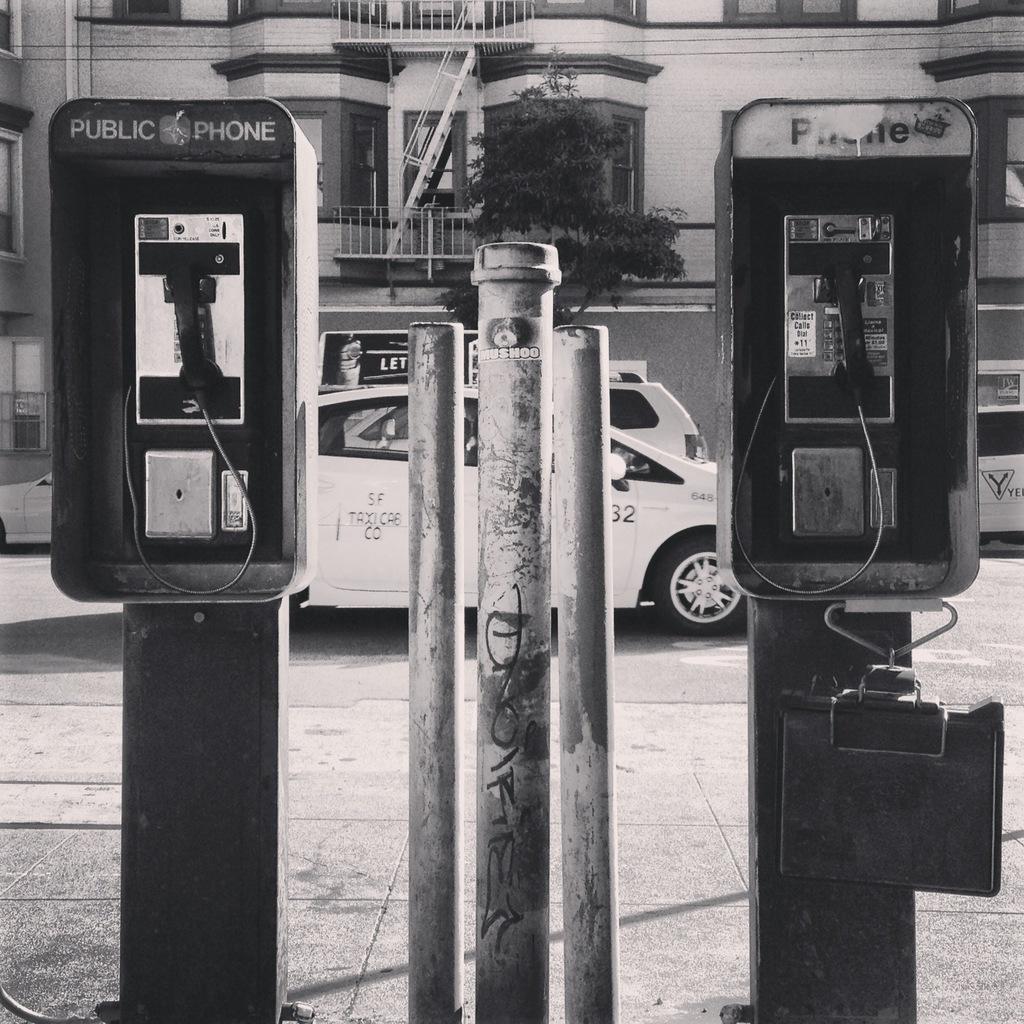What does it say on the top of the pay phone on the left?
Ensure brevity in your answer.  Public phone. Who can use this phone?
Provide a short and direct response. Public. 